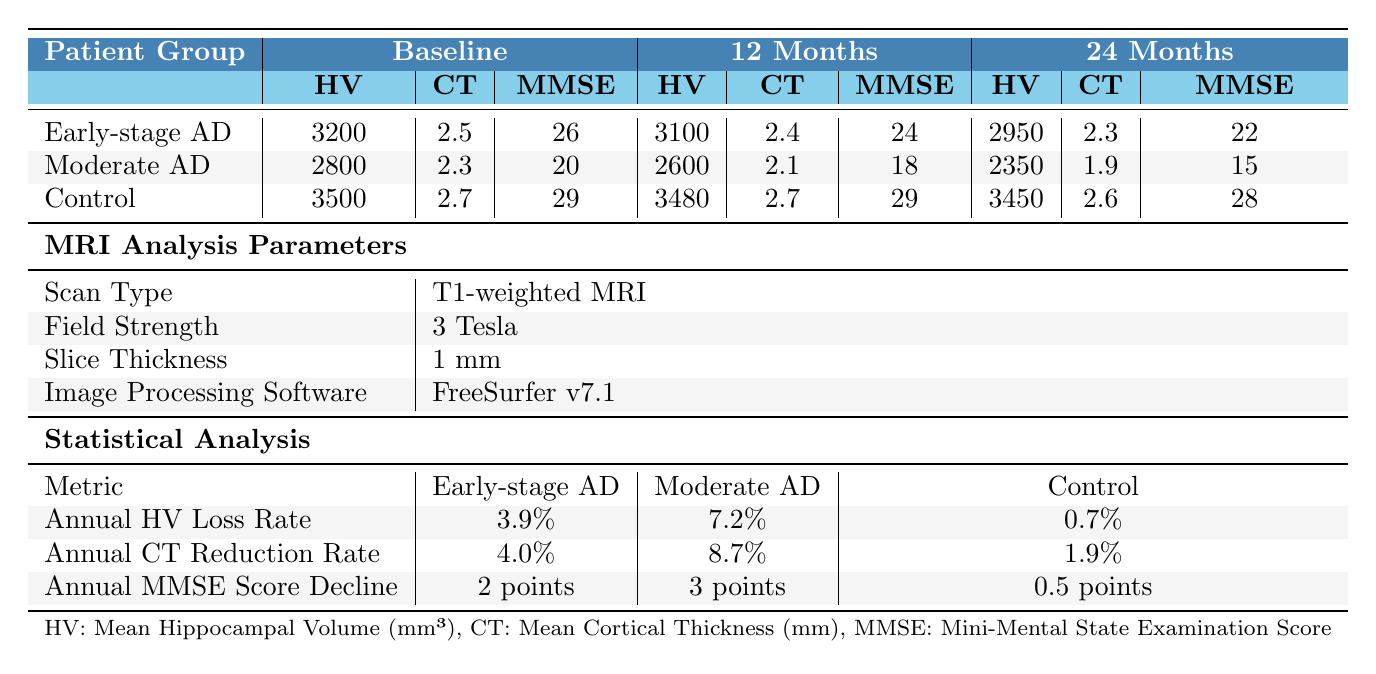What is the Mean Hippocampal Volume for the Moderate AD group at baseline? The table shows that the Mean Hippocampal Volume for the Moderate AD group at baseline is 2800 mm³.
Answer: 2800 mm³ How much did the MMSE score decline for the Early-stage AD group after 24 months? The MMSE score for the Early-stage AD group at baseline is 26, and it is 22 after 24 months. The decline is 26 - 22 = 4 points.
Answer: 4 points What is the average Mean Cortical Thickness across all patient groups at 12 months? For the 12-month data, the Mean Cortical Thickness values are 2.4 mm (Early-stage AD), 2.1 mm (Moderate AD), and 2.7 mm (Control). The average is (2.4 + 2.1 + 2.7) / 3 = 2.4 mm.
Answer: 2.4 mm Is the Annual MMSE Score Decline higher in the Moderate AD group compared to the Early-stage AD group? The Annual MMSE Score Decline for the Moderate AD group is 3 points, while for the Early-stage AD group, it is 2 points. Since 3 is greater than 2, the statement is true.
Answer: Yes At what percentage was the Annual Hippocampal Volume Loss Rate for the Control group? The Annual Hippocampal Volume Loss Rate for the Control group is stated as 0.7% in the statistical analysis section of the table.
Answer: 0.7% Which patient group experienced the highest Annual Cortical Thickness Reduction Rate? The table indicates that the Moderate AD group had the highest Cortical Thickness Reduction Rate at 8.7%.
Answer: Moderate AD What is the total hippocampal volume loss from baseline to 24 months for the Early-stage AD group? The Hippocampal Volume drops from 3200 mm³ (baseline) to 2950 mm³ (24 months). The total loss is 3200 - 2950 = 250 mm³.
Answer: 250 mm³ Is there any change in Mean Cortical Thickness in the Control group from baseline to 12 months? For the Control group, the Mean Cortical Thickness is 2.7 mm at both baseline and 12 months, indicating no change over this period.
Answer: No Which group has the lowest MMSE score at 12 months? The table indicates that the Moderate AD group has the lowest MMSE score at 12 months with a score of 18.
Answer: Moderate AD What is the trend of Mean Hippocampal Volume for the Early-stage AD group over time? The Mean Hippocampal Volume for the Early-stage AD group declines from 3200 mm³ at baseline to 3100 mm³ at 12 months and then to 2950 mm³ at 24 months, showing a continuous decrease.
Answer: Continuous decrease 